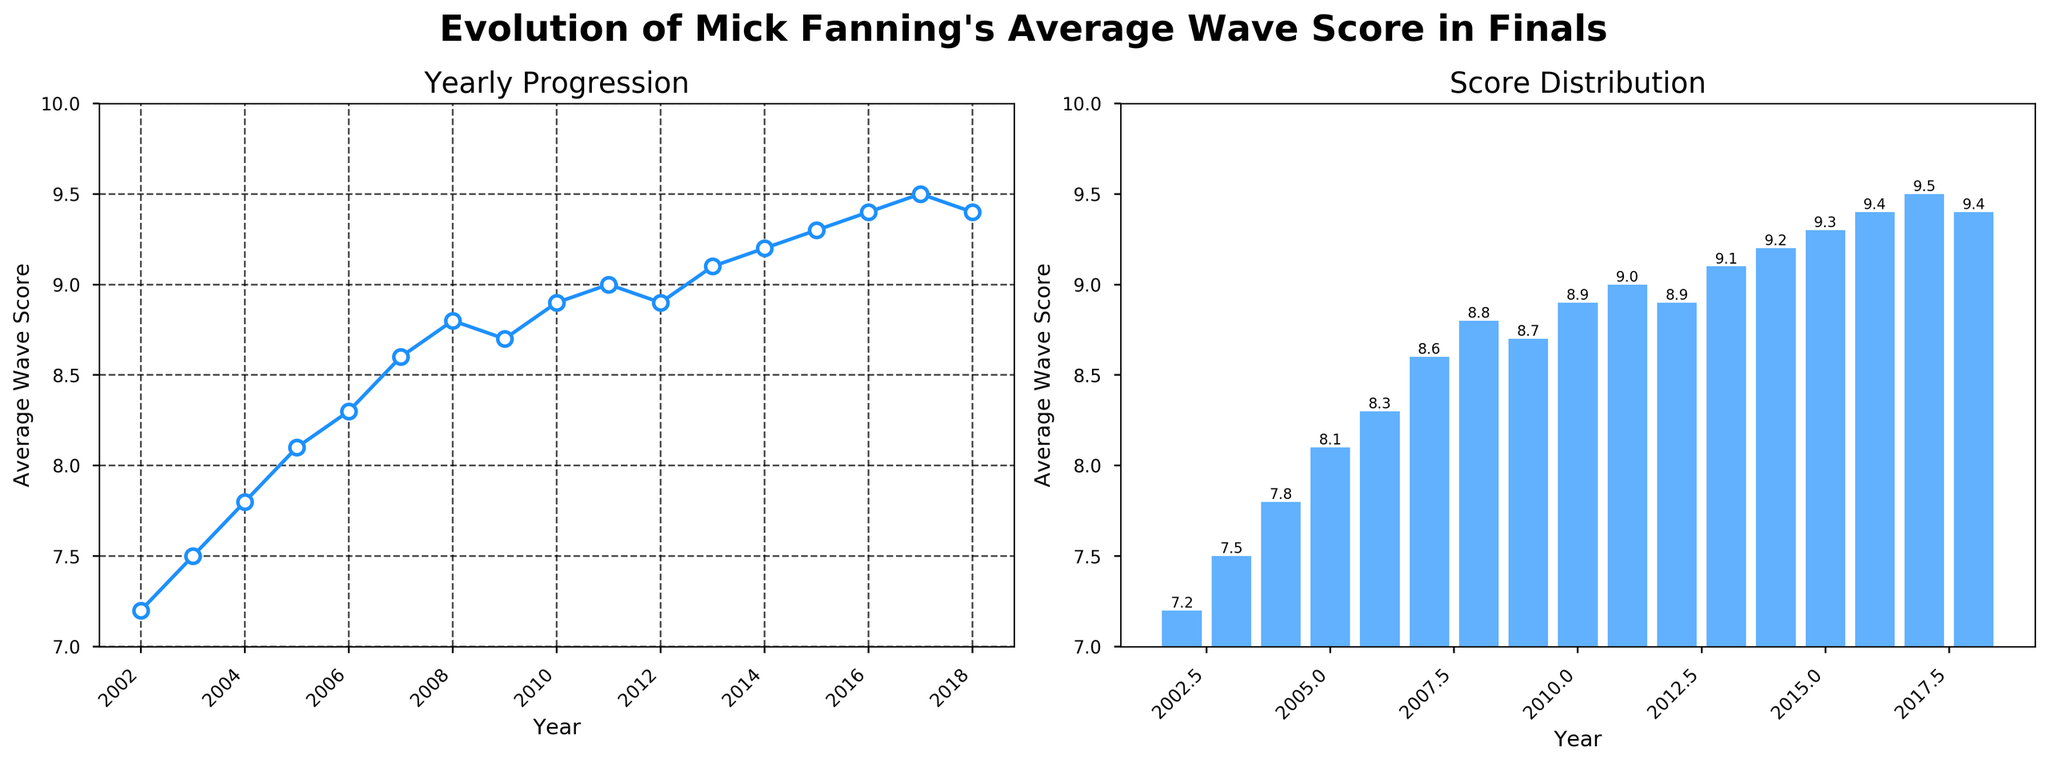What year did Mick Fanning achieve his highest average wave score? From the line and bar plots, Mick Fanning's highest average wave score was in 2017, where the value reaches 9.5.
Answer: 2017 How did Mick Fanning's average wave score change between 2009 and 2010? Observing the line and bar plots, Mick Fanning's average wave score increased from 8.7 in 2009 to 8.9 in 2010, an increase of 0.2.
Answer: Increased by 0.2 Which year showed the first instance of his average wave score reaching 9.0 or higher? By examining the plots, the first year Mick Fanning's average wave score reached 9.0 was in 2011.
Answer: 2011 In which year did Mick Fanning have the lowest average wave score? Based on the visual inspection of the line and bar plots, 2002 shows the lowest average wave score at 7.2.
Answer: 2002 Compare the average wave scores between 2015 and 2017; which year had a higher score and by how much? In the plots, 2015 has an average wave score of 9.3 and 2017 has 9.5. 2017's score is higher by 0.2.
Answer: 2017 by 0.2 What is the overall trend of Mick Fanning's average wave scores over the years? The trend shown in both the line and bar plots is generally increasing, with some small fluctuations, indicating improvement over time.
Answer: Increasing How many years did Mick Fanning have an average wave score of 9.0 or above? By counting the years from the plots where the score is 9.0 or above (2011, 2013, 2014, 2015, 2016, 2017, 2018), there are 7 years.
Answer: 7 What visual cue indicates the evolution of Fanning's performance most clearly between the line and bar plots? The line plot shows the progression continuously, via a connecting line, making it easier to see the trend over time, while the bar chart clearly shows the value of each year.
Answer: Line plot What is the difference in Fanning's average wave scores between 2008 and 2018? From the plots, the average wave score in 2008 is 8.8 and in 2018 is 9.4, resulting in a difference of 0.6.
Answer: 0.6 